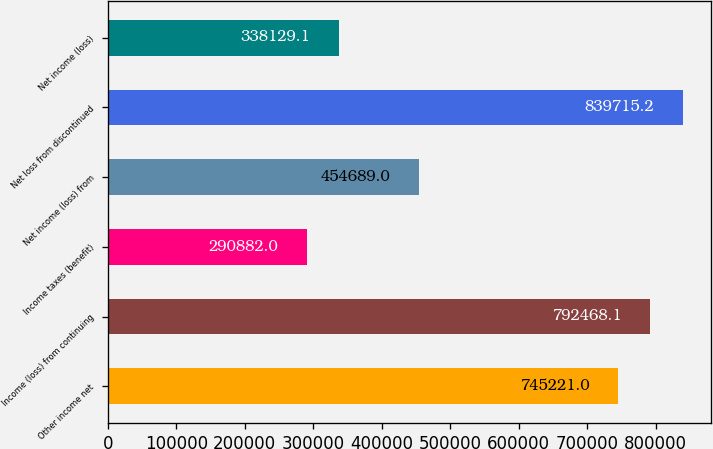<chart> <loc_0><loc_0><loc_500><loc_500><bar_chart><fcel>Other income net<fcel>Income (loss) from continuing<fcel>Income taxes (benefit)<fcel>Net income (loss) from<fcel>Net loss from discontinued<fcel>Net income (loss)<nl><fcel>745221<fcel>792468<fcel>290882<fcel>454689<fcel>839715<fcel>338129<nl></chart> 